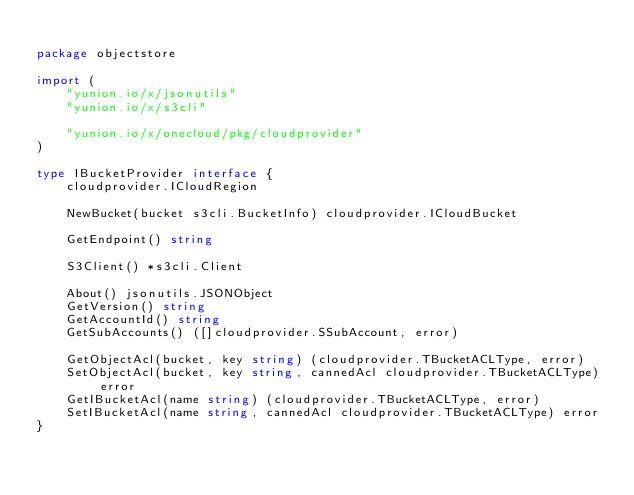Convert code to text. <code><loc_0><loc_0><loc_500><loc_500><_Go_>
package objectstore

import (
	"yunion.io/x/jsonutils"
	"yunion.io/x/s3cli"

	"yunion.io/x/onecloud/pkg/cloudprovider"
)

type IBucketProvider interface {
	cloudprovider.ICloudRegion

	NewBucket(bucket s3cli.BucketInfo) cloudprovider.ICloudBucket

	GetEndpoint() string

	S3Client() *s3cli.Client

	About() jsonutils.JSONObject
	GetVersion() string
	GetAccountId() string
	GetSubAccounts() ([]cloudprovider.SSubAccount, error)

	GetObjectAcl(bucket, key string) (cloudprovider.TBucketACLType, error)
	SetObjectAcl(bucket, key string, cannedAcl cloudprovider.TBucketACLType) error
	GetIBucketAcl(name string) (cloudprovider.TBucketACLType, error)
	SetIBucketAcl(name string, cannedAcl cloudprovider.TBucketACLType) error
}
</code> 